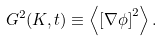<formula> <loc_0><loc_0><loc_500><loc_500>G ^ { 2 } ( K , t ) \equiv \left \langle \left [ \nabla \phi \right ] ^ { 2 } \right \rangle .</formula> 